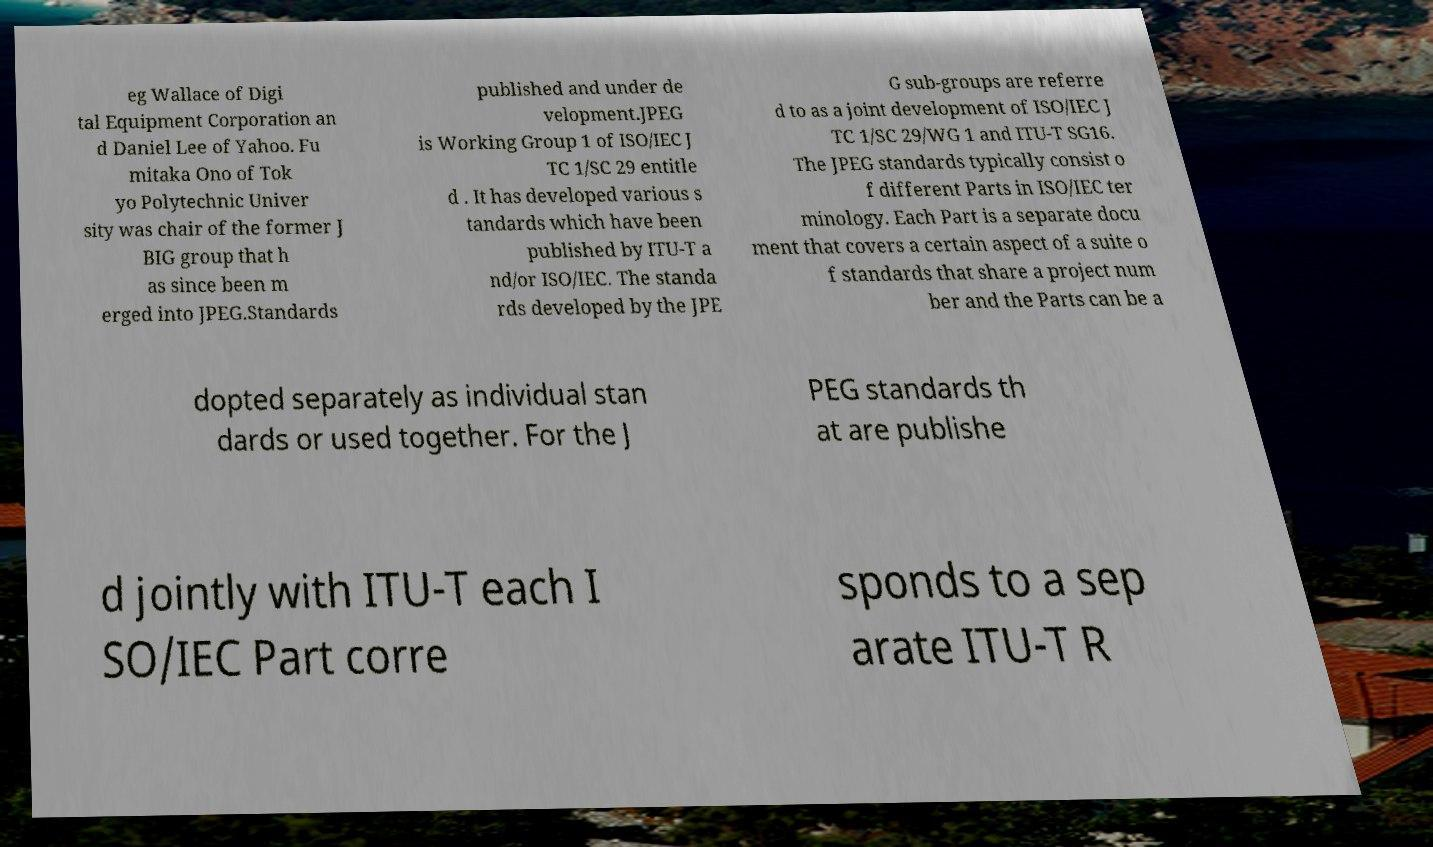What messages or text are displayed in this image? I need them in a readable, typed format. eg Wallace of Digi tal Equipment Corporation an d Daniel Lee of Yahoo. Fu mitaka Ono of Tok yo Polytechnic Univer sity was chair of the former J BIG group that h as since been m erged into JPEG.Standards published and under de velopment.JPEG is Working Group 1 of ISO/IEC J TC 1/SC 29 entitle d . It has developed various s tandards which have been published by ITU-T a nd/or ISO/IEC. The standa rds developed by the JPE G sub-groups are referre d to as a joint development of ISO/IEC J TC 1/SC 29/WG 1 and ITU-T SG16. The JPEG standards typically consist o f different Parts in ISO/IEC ter minology. Each Part is a separate docu ment that covers a certain aspect of a suite o f standards that share a project num ber and the Parts can be a dopted separately as individual stan dards or used together. For the J PEG standards th at are publishe d jointly with ITU-T each I SO/IEC Part corre sponds to a sep arate ITU-T R 